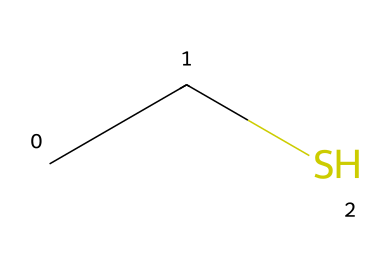What is the molecular formula of ethanethiol? The molecular formula can be derived from the SMILES representation "CCS," which indicates two carbon atoms (C), six hydrogen atoms (H), and one sulfur atom (S). Putting this together gives the formula C2H6S.
Answer: C2H6S How many carbon atoms are present in ethanethiol? By examining the SMILES notation "CCS," we clearly see there are two 'C' characters, indicating two carbon atoms in the structure.
Answer: 2 What type of functional group is present in ethanethiol? Ethanethiol contains a thiol functional group, as indicated by the presence of the sulfur atom (S) directly bonded to a carbon atom, characteristic of thiols which have the -SH group.
Answer: thiol What is the total number of hydrogen atoms in ethanethiol? In the chemical structure "CCS," there are a total of six 'H' implied by the connections of the two carbon atoms to form a saturated compound, confirming the presence of six hydrogen atoms.
Answer: 6 What characteristic odor is associated with ethanethiol? Ethanethiol is known for having a strong foul or rotten odor, which is why it is used as an odorant in natural gas for leak detection; this characteristic is common for many organosulfur compounds.
Answer: foul How does the presence of sulfur in ethanethiol influence its properties? The sulfur atom significantly affects the chemical properties of ethanethiol by imparting a distinct odor, lower boiling point compared to alcohols, and increased reactivity due to sulfur's electronegativity compared to carbon.
Answer: distinct odor Why is ethanethiol added to natural gas? Ethanethiol is added to natural gas for safety reasons, specifically to provide a strong odor for leak detection, allowing individuals to smell leaks quickly; this is a critical safety measure in airport facilities.
Answer: safety measure 